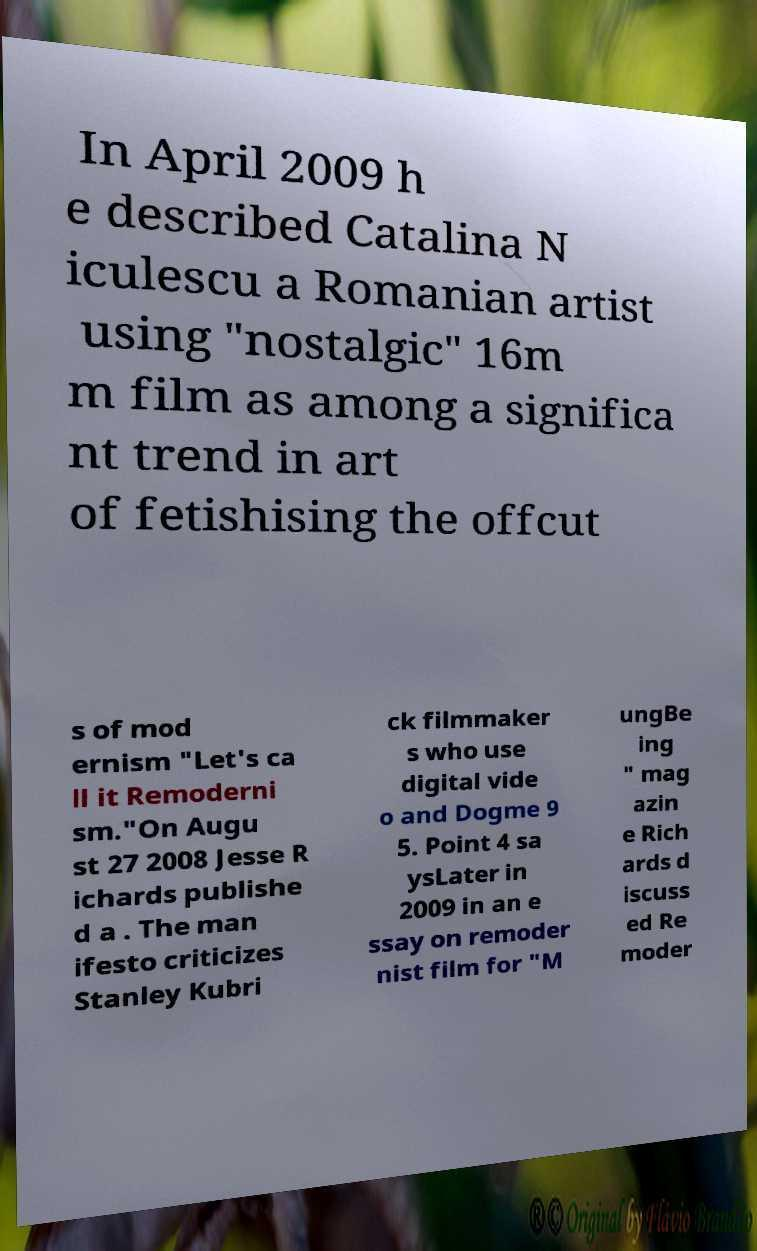Could you extract and type out the text from this image? In April 2009 h e described Catalina N iculescu a Romanian artist using "nostalgic" 16m m film as among a significa nt trend in art of fetishising the offcut s of mod ernism "Let's ca ll it Remoderni sm."On Augu st 27 2008 Jesse R ichards publishe d a . The man ifesto criticizes Stanley Kubri ck filmmaker s who use digital vide o and Dogme 9 5. Point 4 sa ysLater in 2009 in an e ssay on remoder nist film for "M ungBe ing " mag azin e Rich ards d iscuss ed Re moder 